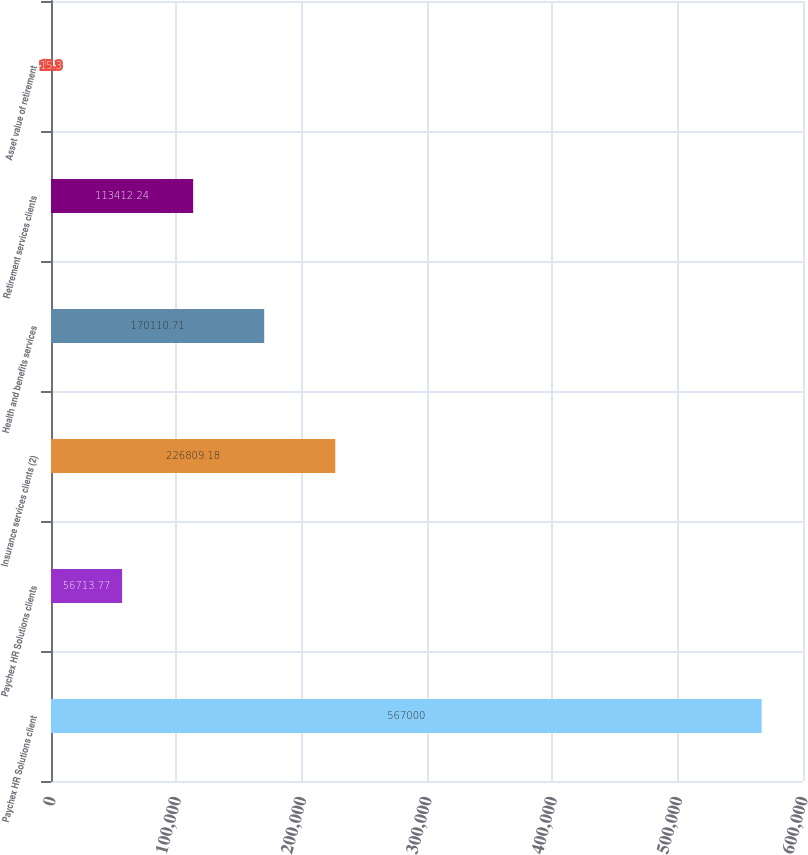Convert chart to OTSL. <chart><loc_0><loc_0><loc_500><loc_500><bar_chart><fcel>Paychex HR Solutions client<fcel>Paychex HR Solutions clients<fcel>Insurance services clients (2)<fcel>Health and benefits services<fcel>Retirement services clients<fcel>Asset value of retirement<nl><fcel>567000<fcel>56713.8<fcel>226809<fcel>170111<fcel>113412<fcel>15.3<nl></chart> 